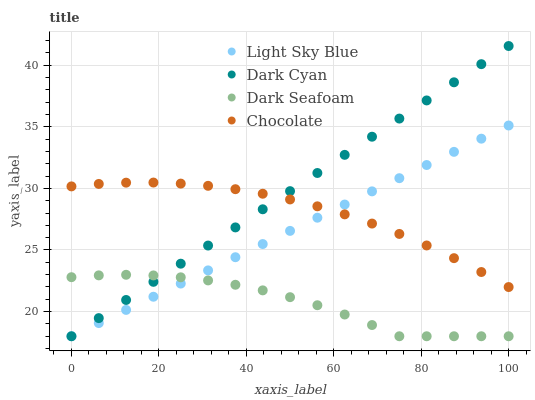Does Dark Seafoam have the minimum area under the curve?
Answer yes or no. Yes. Does Dark Cyan have the maximum area under the curve?
Answer yes or no. Yes. Does Light Sky Blue have the minimum area under the curve?
Answer yes or no. No. Does Light Sky Blue have the maximum area under the curve?
Answer yes or no. No. Is Light Sky Blue the smoothest?
Answer yes or no. Yes. Is Dark Seafoam the roughest?
Answer yes or no. Yes. Is Dark Seafoam the smoothest?
Answer yes or no. No. Is Light Sky Blue the roughest?
Answer yes or no. No. Does Dark Cyan have the lowest value?
Answer yes or no. Yes. Does Chocolate have the lowest value?
Answer yes or no. No. Does Dark Cyan have the highest value?
Answer yes or no. Yes. Does Light Sky Blue have the highest value?
Answer yes or no. No. Is Dark Seafoam less than Chocolate?
Answer yes or no. Yes. Is Chocolate greater than Dark Seafoam?
Answer yes or no. Yes. Does Dark Cyan intersect Light Sky Blue?
Answer yes or no. Yes. Is Dark Cyan less than Light Sky Blue?
Answer yes or no. No. Is Dark Cyan greater than Light Sky Blue?
Answer yes or no. No. Does Dark Seafoam intersect Chocolate?
Answer yes or no. No. 